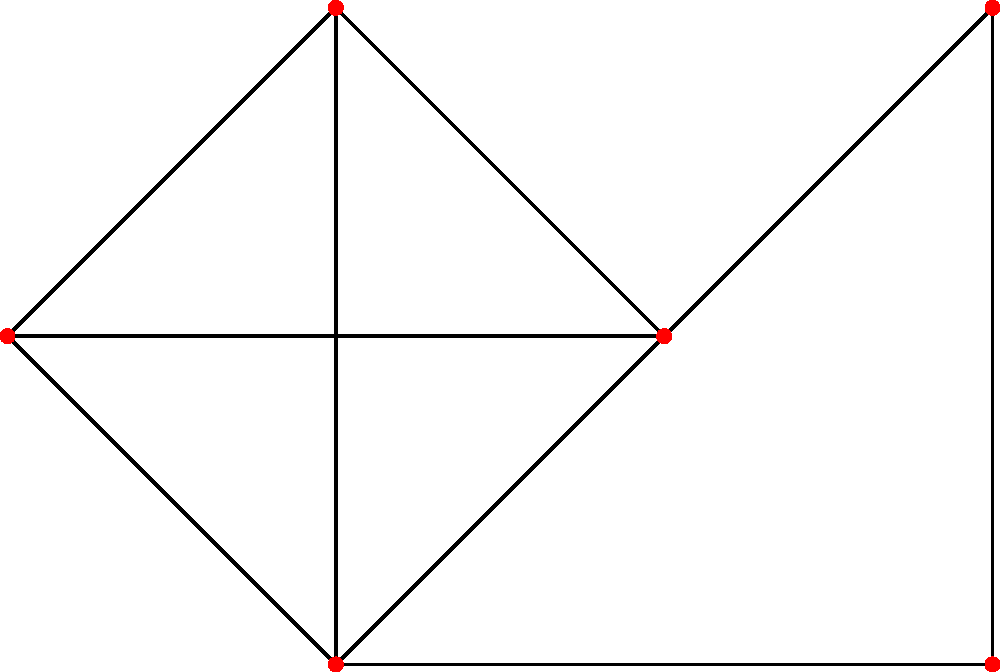As a software engineer in a Nigerian tech startup, you're tasked with optimizing a resource allocation algorithm. The problem can be modeled as a graph coloring problem, where each node represents a resource and edges represent conflicts. Given the graph above, what is the minimum number of colors (representing different time slots) needed to color all nodes such that no two adjacent nodes have the same color? To solve this graph coloring problem, we'll use the greedy coloring algorithm:

1. Start with the first vertex and assign it the first color.
2. Move to the next vertex and assign it the first available color that hasn't been used by its adjacent vertices.
3. Repeat step 2 for all vertices.

Let's color the vertices step by step:

1. Assign color 1 to vertex 1.
2. For vertex 2:
   - It's adjacent to vertex 1, so we can't use color 1.
   - Assign color 2 to vertex 2.
3. For vertex 3:
   - It's adjacent to vertices 1 and 2, so we can't use colors 1 or 2.
   - Assign color 3 to vertex 3.
4. For vertex 4:
   - It's adjacent to vertices 1, 2, and 3.
   - We can use color 1 for vertex 4 as it's not used by any adjacent vertex.
5. For vertex 5:
   - It's adjacent to vertices 2 and 3.
   - We can use color 1 for vertex 5.
6. For vertex 6:
   - It's adjacent to vertices 3, 4, and 5.
   - We can use color 2 for vertex 6.

After coloring all vertices, we find that we used a total of 3 colors.

To prove this is the minimum:
- Vertices 1, 2, and 3 form a triangle, requiring 3 different colors.
- No other combination of vertices requires more than 3 colors.

Therefore, the minimum number of colors needed is 3.
Answer: 3 colors 